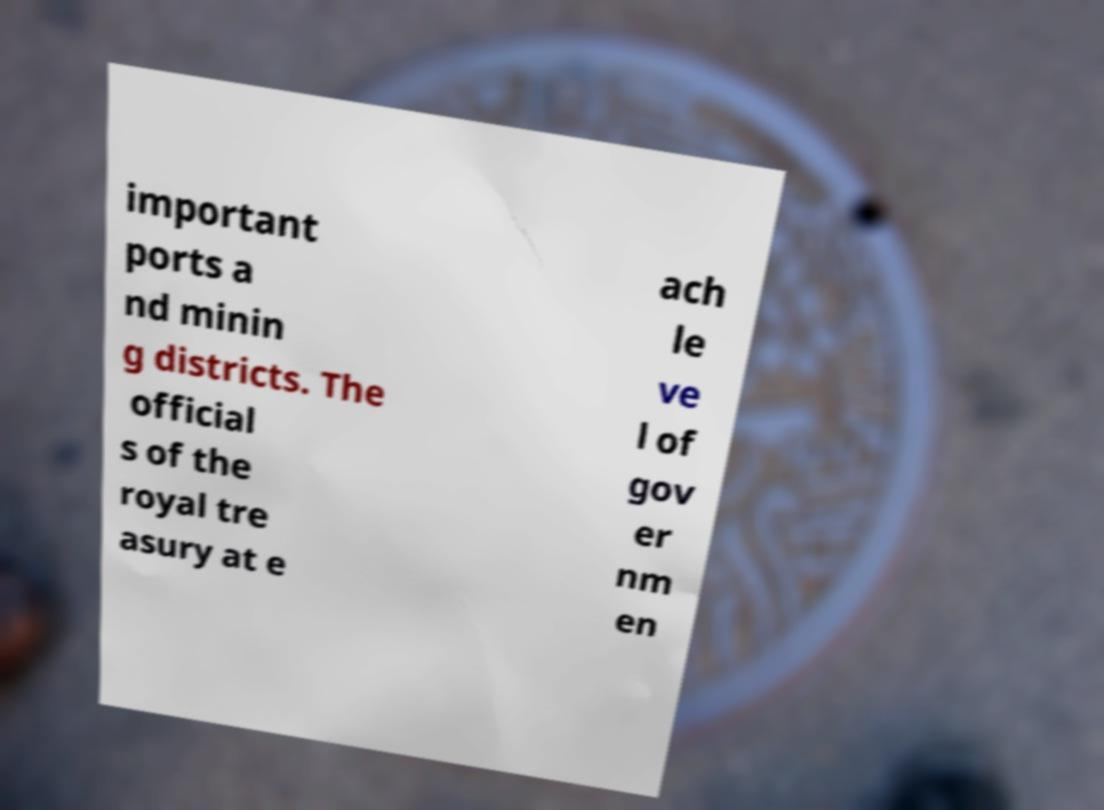Can you accurately transcribe the text from the provided image for me? important ports a nd minin g districts. The official s of the royal tre asury at e ach le ve l of gov er nm en 